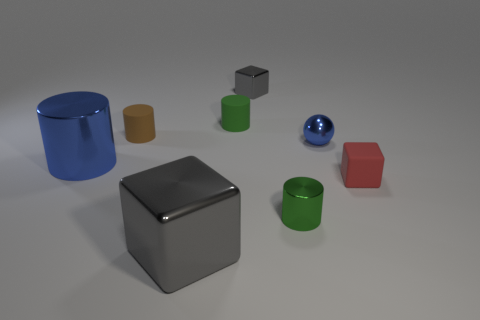The small cube that is the same material as the brown thing is what color?
Offer a terse response. Red. What number of green cylinders have the same material as the tiny red cube?
Your answer should be compact. 1. Do the gray object in front of the red rubber thing and the blue ball have the same size?
Your answer should be very brief. No. The metal cube that is the same size as the green metallic cylinder is what color?
Your answer should be compact. Gray. There is a green rubber thing; what number of gray cubes are to the right of it?
Offer a terse response. 1. Are any tiny brown cylinders visible?
Ensure brevity in your answer.  Yes. What is the size of the gray metal cube to the left of the gray shiny object behind the blue thing that is in front of the small blue shiny ball?
Offer a very short reply. Large. What number of other things are the same size as the blue ball?
Ensure brevity in your answer.  5. There is a metallic thing in front of the small metal cylinder; how big is it?
Keep it short and to the point. Large. Is there any other thing of the same color as the small shiny cylinder?
Your answer should be very brief. Yes. 